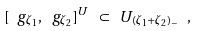<formula> <loc_0><loc_0><loc_500><loc_500>[ \ g _ { \zeta _ { 1 } } , \ g _ { \zeta _ { 2 } } ] ^ { U } \ \subset \ U _ { ( \zeta _ { 1 } + \zeta _ { 2 } ) _ { - } } \ ,</formula> 